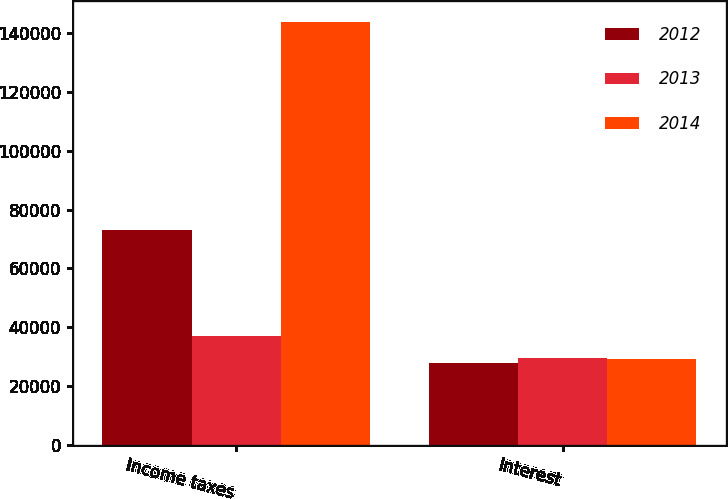<chart> <loc_0><loc_0><loc_500><loc_500><stacked_bar_chart><ecel><fcel>Income taxes<fcel>Interest<nl><fcel>2012<fcel>73067<fcel>27931<nl><fcel>2013<fcel>36863<fcel>29354<nl><fcel>2014<fcel>143899<fcel>29177<nl></chart> 